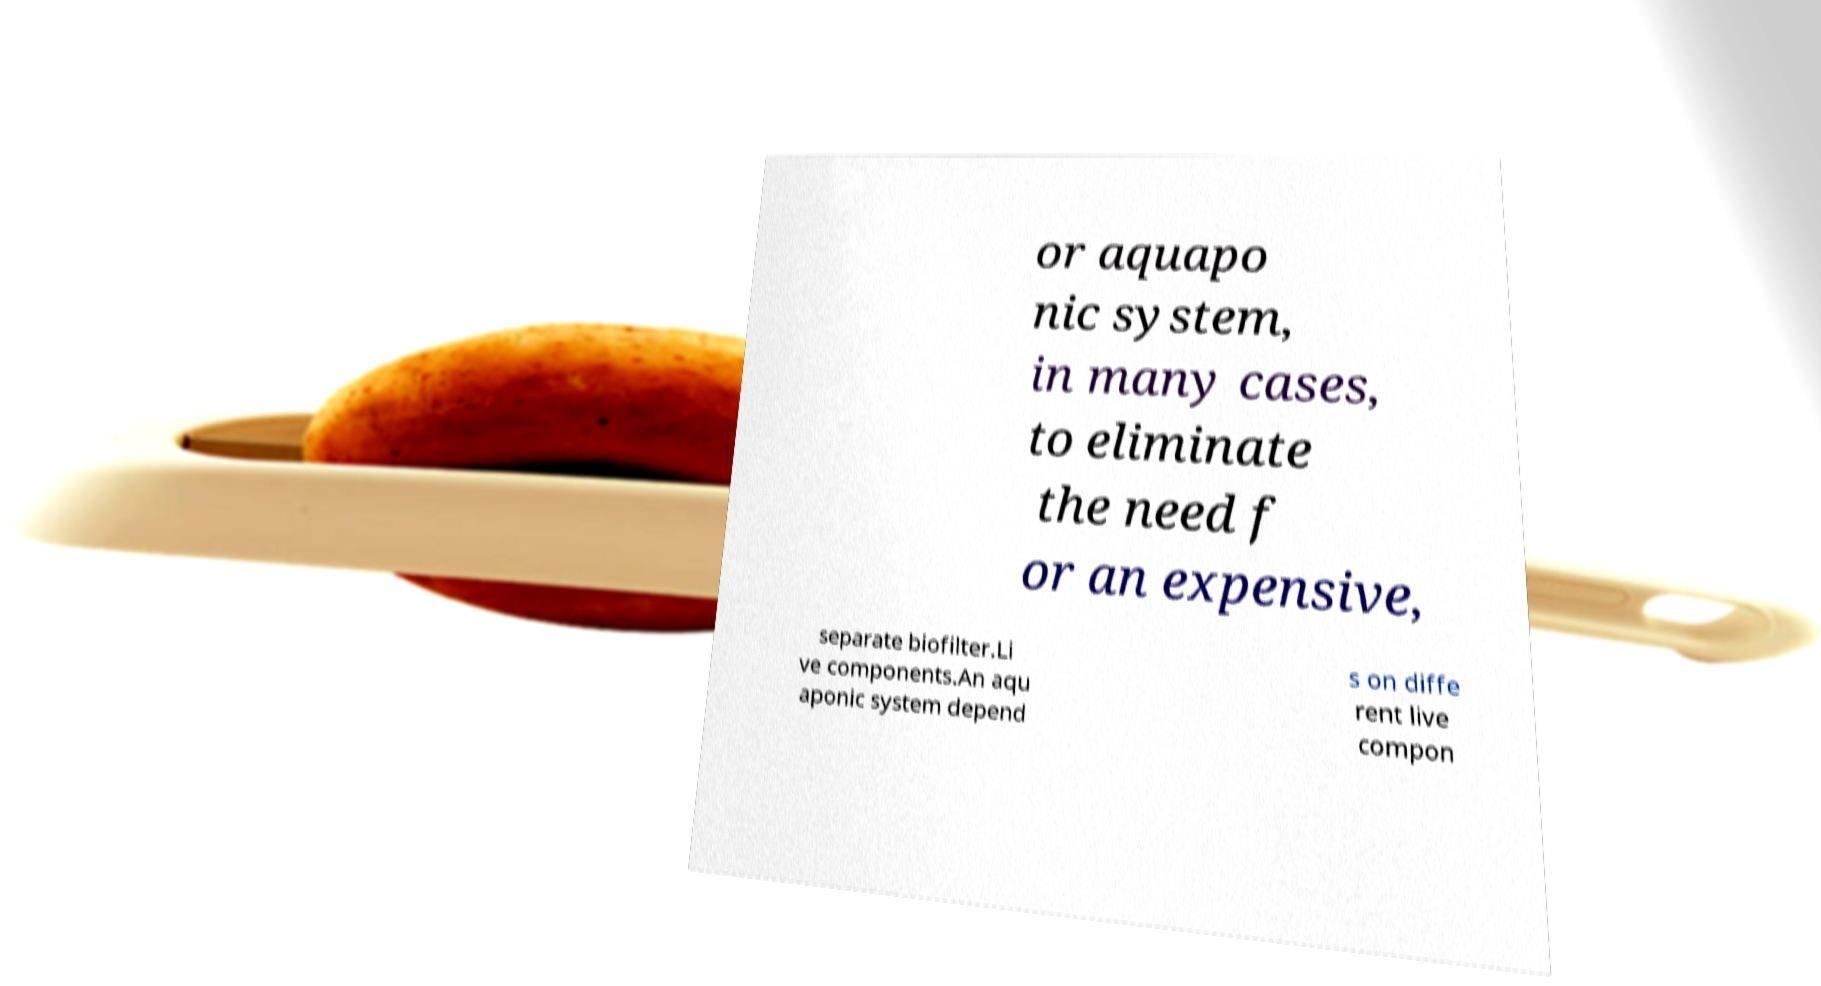Can you read and provide the text displayed in the image?This photo seems to have some interesting text. Can you extract and type it out for me? or aquapo nic system, in many cases, to eliminate the need f or an expensive, separate biofilter.Li ve components.An aqu aponic system depend s on diffe rent live compon 